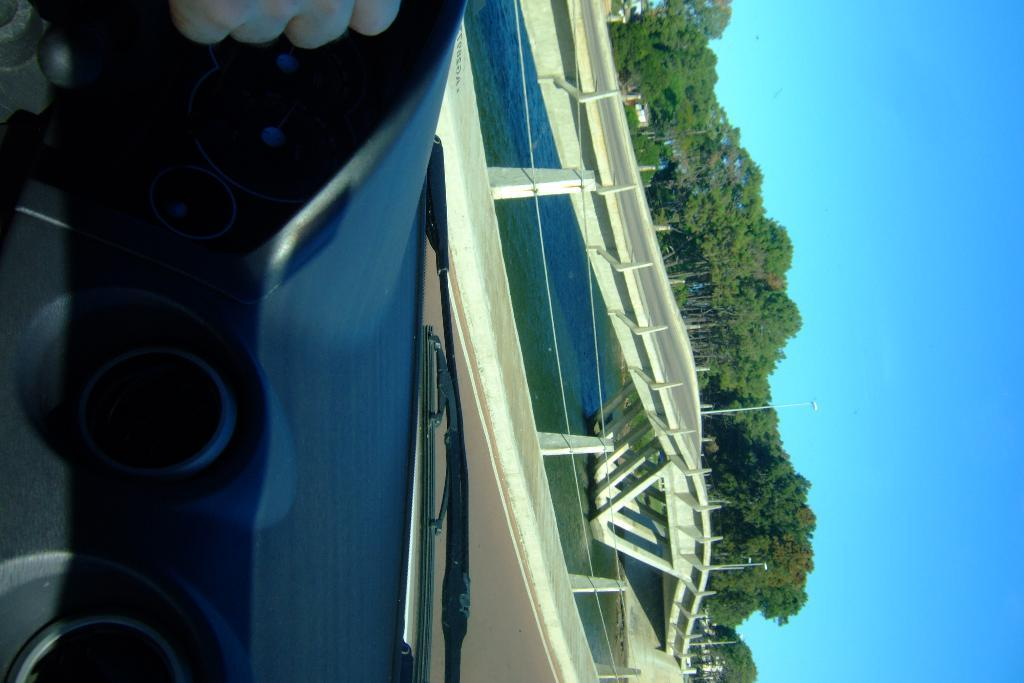What type of natural elements can be seen in the image? There are trees in the image. What man-made structure is present in the image? There is a bridge in the image. What other objects can be seen in the image? There are poles and fencing in the image. What is the water feature in the image? There is water visible in the image. What part of a vehicle is visible in the image? The inner part of a vehicle is visible in the image. How does the feeling of loss affect the competition in the image? There is no mention of feelings or competition in the image; it features trees, a bridge, poles, fencing, water, and the interior of a vehicle. 